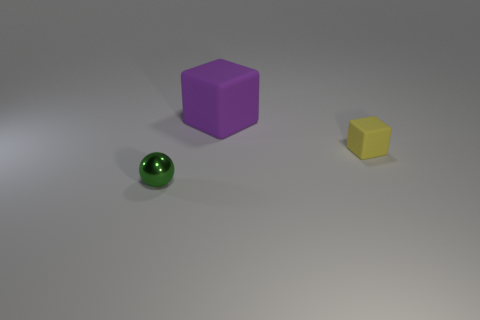Add 2 purple blocks. How many objects exist? 5 Subtract all spheres. How many objects are left? 2 Add 2 small yellow things. How many small yellow things are left? 3 Add 1 yellow matte objects. How many yellow matte objects exist? 2 Subtract 0 cyan cylinders. How many objects are left? 3 Subtract all blocks. Subtract all tiny yellow rubber things. How many objects are left? 0 